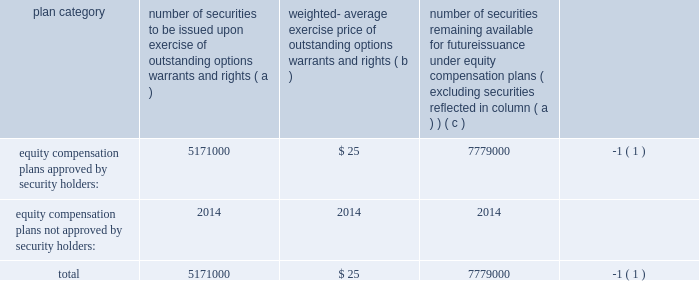Item 11 2014executive compensation we incorporate by reference in this item 11 the information relating to executive and director compensation contained under the headings 201cother information about the board and its committees , 201d 201ccompensation and other benefits 201d and 201creport of the compensation committee 201d from our proxy statement to be delivered in connection with our 2007 annual meeting of shareholders to be held on september 26 , 2007 .
Item 12 2014security ownership of certain beneficial owners andmanagement and related stockholdermatters we incorporate by reference in this item 12 the information relating to ownership of our common stock by certain persons contained under the headings 201ccommon stock ownership of management 201d and 201ccommon stock ownership by certain other persons 201d from our proxy statement to be delivered in connection with our 2007 annual meeting of shareholders to be held on september 26 , 2007 .
We have four compensation plans under which our equity securities are authorized for issuance .
The global payments inc .
Amended and restated 2000 long-term incentive plan , global payments inc .
Amended and restated 2005 incentive plan , the non-employee director stock option plan , and employee stock purchase plan have been approved by security holders .
The information in the table below is as of may 31 , 2007 .
For more information on these plans , see note 8 to notes to consolidated financial statements .
Plan category number of securities to be issued upon exercise of outstanding options , warrants and rights weighted- average exercise price of outstanding options , warrants and rights number of securities remaining available for future issuance under equity compensation plans ( excluding securities reflected in column ( a ) ) equity compensation plans approved by security holders: .
5171000 $ 25 7779000 ( 1 ) equity compensation plans not approved by security holders: .
2014 2014 2014 total .
5171000 $ 25 7779000 ( 1 ) ( 1 ) also includes shares of common stock available for issuance other than upon the exercise of an option , warrant or right under the amended and restated 2000 non-employee director stock option plan , the amended and restated 2005 incentive plan and the amended and restated 2000 employee stock purchase item 13 2014certain relationships and related transactions , and director independence we incorporate by reference in this item 13 the information regarding certain relationships and related transactions between us and some of our affiliates and the independence of our board of directors contained under the headings 201ccertain relationships and related transactions 201d and 201cother information about the board and its committees 2014director independence 201d from our proxy statement to be delivered in connection with our 2007 annual meeting of shareholders to be held on september 26 , 2007 .
Item 14 2014principal accounting fees and services we incorporate by reference in this item 14 the information regarding principal accounting fees and services contained under the heading 201cauditor information 201d from our proxy statement to be delivered in connection with our 2007 annual meeting of shareholders to be held on september 26 , 2007. .
Item 11 2014executive compensation we incorporate by reference in this item 11 the information relating to executive and director compensation contained under the headings 201cother information about the board and its committees , 201d 201ccompensation and other benefits 201d and 201creport of the compensation committee 201d from our proxy statement to be delivered in connection with our 2007 annual meeting of shareholders to be held on september 26 , 2007 .
Item 12 2014security ownership of certain beneficial owners andmanagement and related stockholdermatters we incorporate by reference in this item 12 the information relating to ownership of our common stock by certain persons contained under the headings 201ccommon stock ownership of management 201d and 201ccommon stock ownership by certain other persons 201d from our proxy statement to be delivered in connection with our 2007 annual meeting of shareholders to be held on september 26 , 2007 .
We have four compensation plans under which our equity securities are authorized for issuance .
The global payments inc .
Amended and restated 2000 long-term incentive plan , global payments inc .
Amended and restated 2005 incentive plan , the non-employee director stock option plan , and employee stock purchase plan have been approved by security holders .
The information in the table below is as of may 31 , 2007 .
For more information on these plans , see note 8 to notes to consolidated financial statements .
Plan category number of securities to be issued upon exercise of outstanding options , warrants and rights weighted- average exercise price of outstanding options , warrants and rights number of securities remaining available for future issuance under equity compensation plans ( excluding securities reflected in column ( a ) ) equity compensation plans approved by security holders: .
5171000 $ 25 7779000 ( 1 ) equity compensation plans not approved by security holders: .
2014 2014 2014 total .
5171000 $ 25 7779000 ( 1 ) ( 1 ) also includes shares of common stock available for issuance other than upon the exercise of an option , warrant or right under the amended and restated 2000 non-employee director stock option plan , the amended and restated 2005 incentive plan and the amended and restated 2000 employee stock purchase item 13 2014certain relationships and related transactions , and director independence we incorporate by reference in this item 13 the information regarding certain relationships and related transactions between us and some of our affiliates and the independence of our board of directors contained under the headings 201ccertain relationships and related transactions 201d and 201cother information about the board and its committees 2014director independence 201d from our proxy statement to be delivered in connection with our 2007 annual meeting of shareholders to be held on september 26 , 2007 .
Item 14 2014principal accounting fees and services we incorporate by reference in this item 14 the information regarding principal accounting fees and services contained under the heading 201cauditor information 201d from our proxy statement to be delivered in connection with our 2007 annual meeting of shareholders to be held on september 26 , 2007. .
What is the total number of approved securities by the security holders? 
Computations: (5171000 + 7779000)
Answer: 12950000.0. 